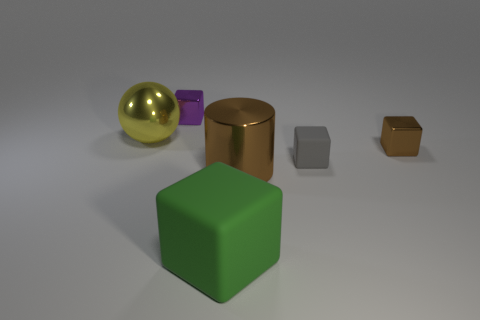Subtract all brown metallic blocks. How many blocks are left? 3 Add 3 big metal objects. How many objects exist? 9 Subtract 2 blocks. How many blocks are left? 2 Subtract all brown blocks. How many blocks are left? 3 Subtract all balls. How many objects are left? 5 Add 5 large blue matte cubes. How many large blue matte cubes exist? 5 Subtract 1 yellow balls. How many objects are left? 5 Subtract all blue spheres. Subtract all red cylinders. How many spheres are left? 1 Subtract all cyan metallic things. Subtract all yellow spheres. How many objects are left? 5 Add 2 small purple metallic cubes. How many small purple metallic cubes are left? 3 